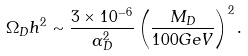Convert formula to latex. <formula><loc_0><loc_0><loc_500><loc_500>\Omega _ { D } h ^ { 2 } \sim \frac { 3 \times 1 0 ^ { - 6 } } { \alpha _ { D } ^ { 2 } } \left ( \frac { M _ { D } } { 1 0 0 { G e V } } \right ) ^ { 2 } .</formula> 